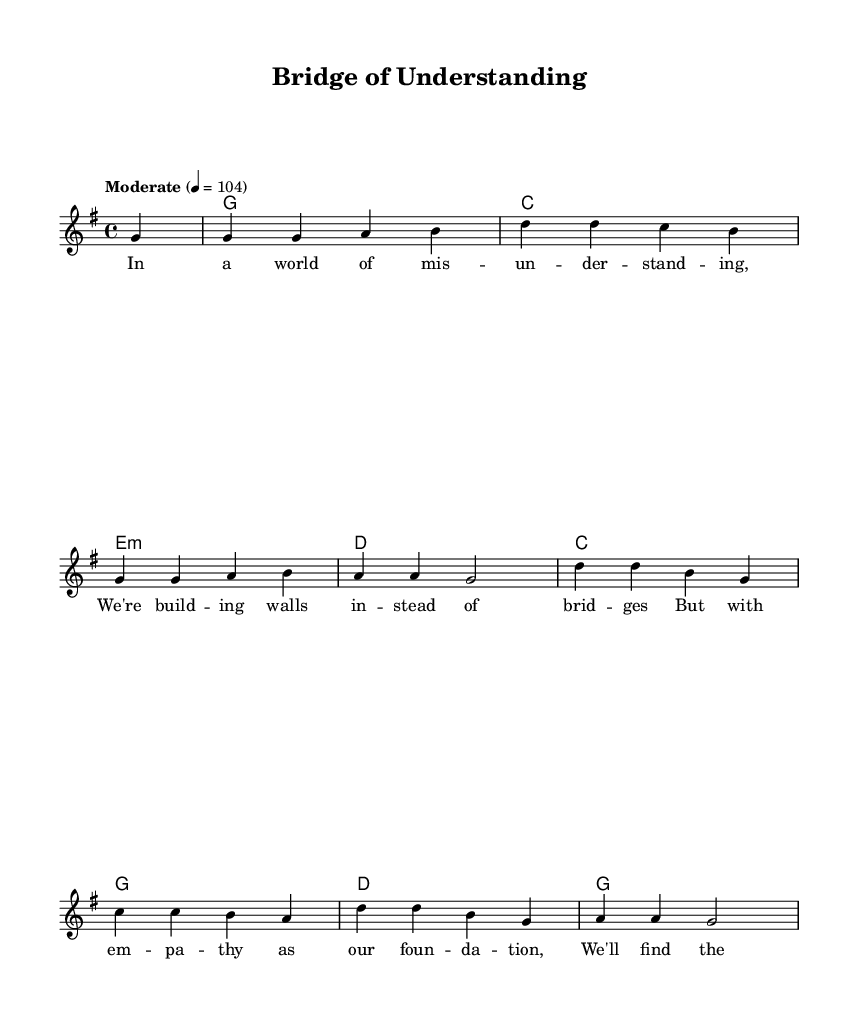What is the key signature of this music? The key signature is G major, which has one sharp (F#).
Answer: G major What is the time signature of this piece? The time signature is 4/4, indicating that there are four beats in each measure.
Answer: 4/4 What is the tempo marking for this piece? The tempo marking indicates a moderate speed of 104 beats per minute.
Answer: 104 How many measures are in the melody section? By counting the measures in the melody part, there are a total of eight measures.
Answer: 8 What is the chord progression for the first two measures? The first two measures have a chord progression of G major for the first measure and C major for the second measure.
Answer: G, C Why is empathy mentioned as a foundation in the lyrics? Empathy is described as a foundation since it allows for better listening and understanding, fostering peace and connection in relationships.
Answer: Better listening How does the structure of this song reflect Country Rock characteristics? The structure includes storytelling through lyrics, a straightforward chord progression, and melodies that are catchy and easy to sing along to, which are typical of Country Rock.
Answer: Storytelling 